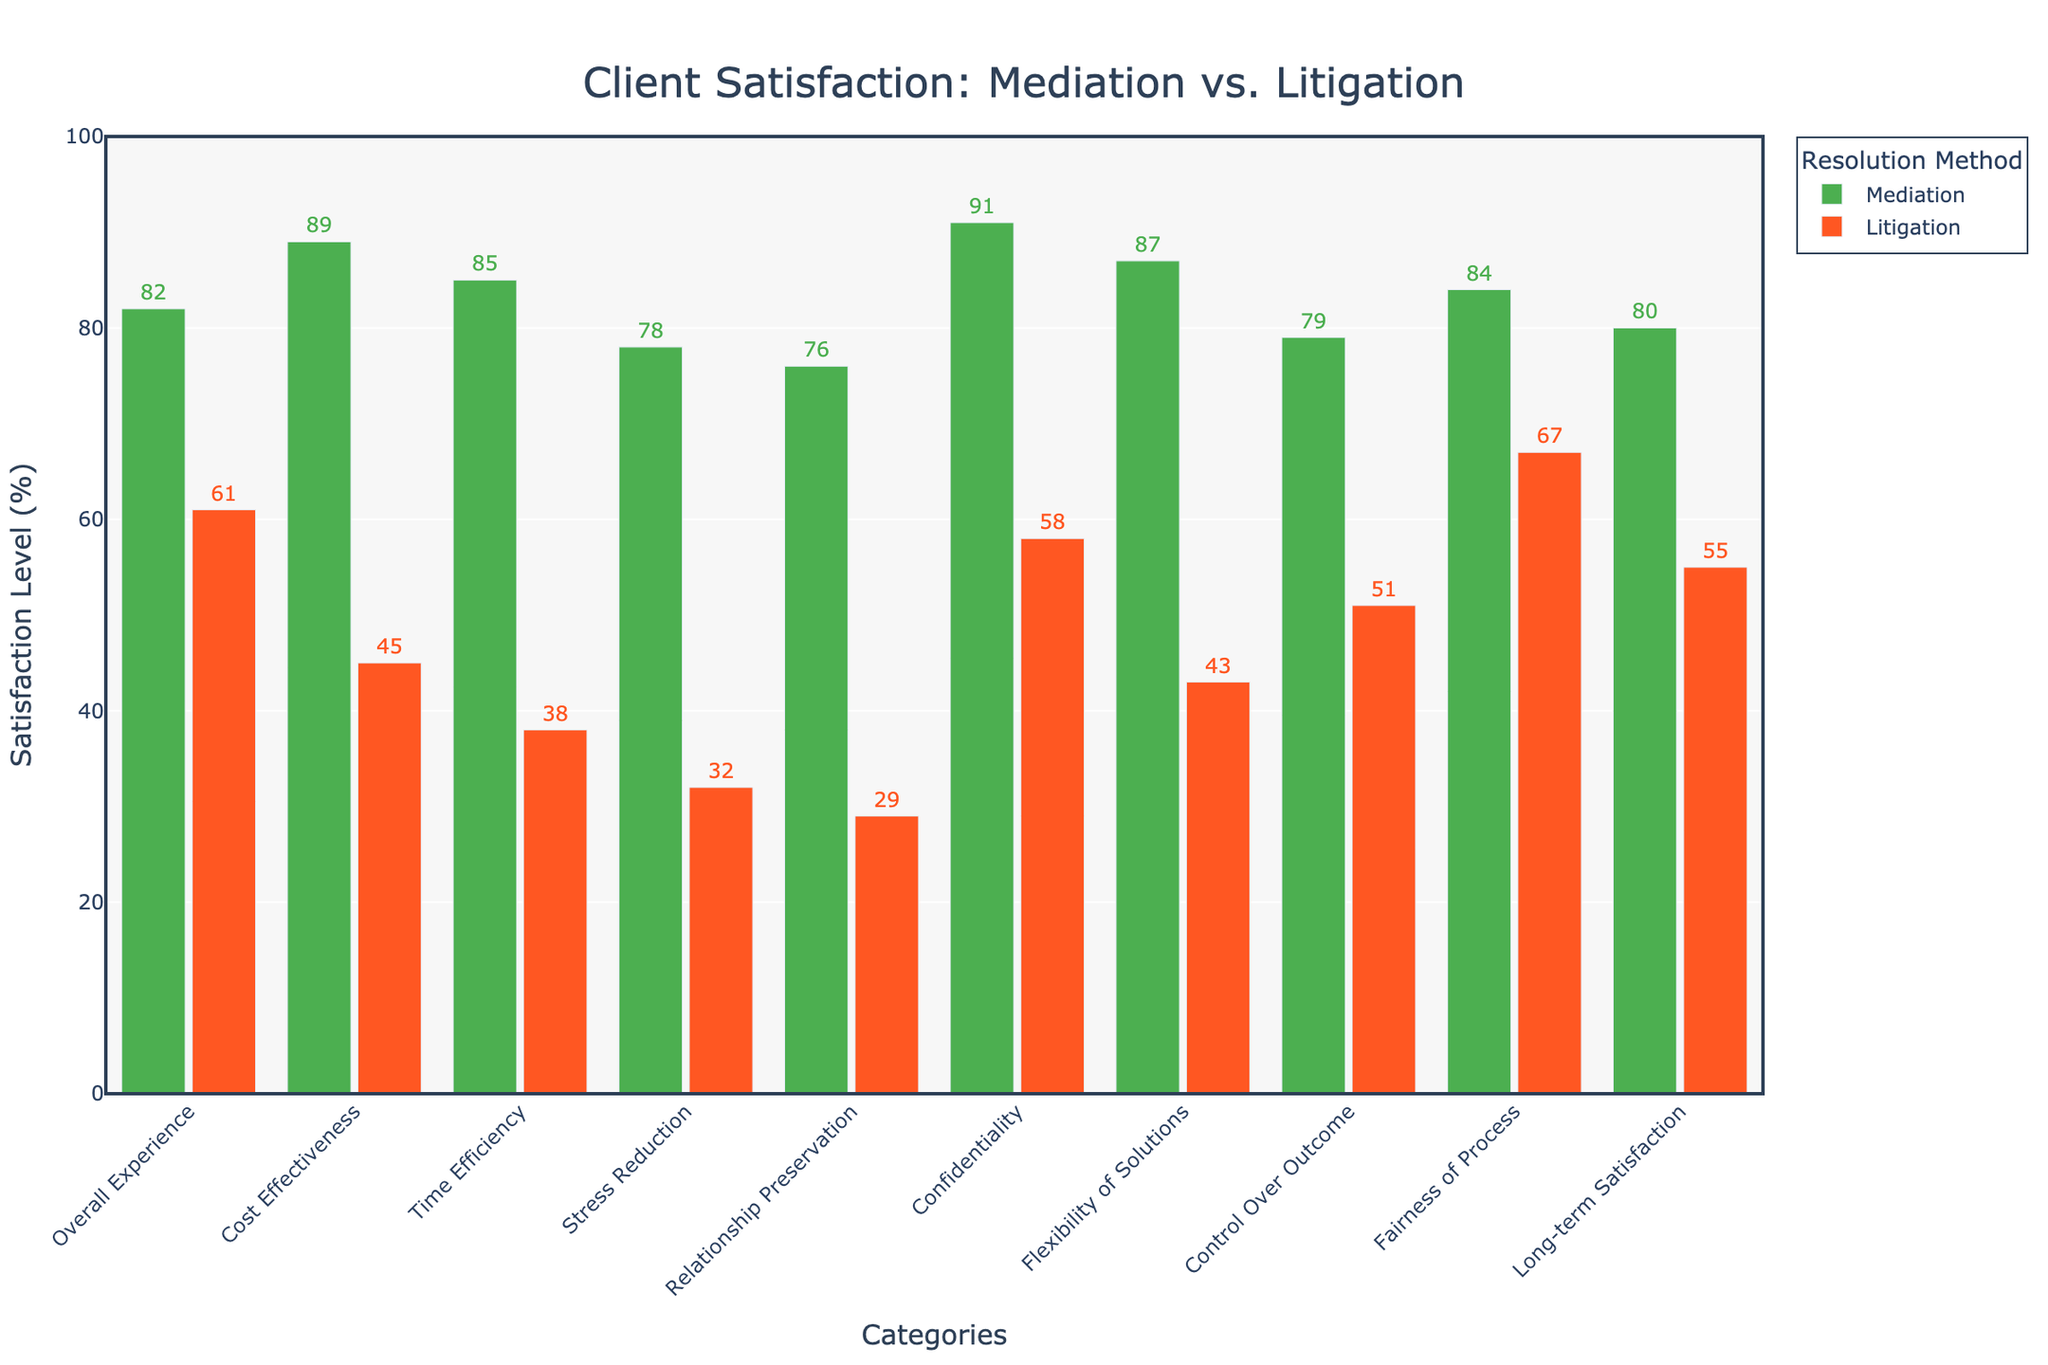Does Mediation or Litigation have a higher overall satisfaction level? To find which method has a higher overall satisfaction level, compare the heights of the bars for "Overall Experience" in the two methods. The bar for Mediation is taller, indicating a higher satisfaction level.
Answer: Mediation Which category shows the largest difference in satisfaction between Mediation and Litigation? To determine the category with the largest difference, calculate the differences for each category: Overall Experience (21%), Cost Effectiveness (44%), Time Efficiency (47%), Stress Reduction (46%), Relationship Preservation (47%), Confidentiality (33%), Flexibility of Solutions (44%), Control Over Outcome (28%), Fairness of Process (17%), Long-term Satisfaction (25%). Time Efficiency and Relationship Preservation both have a difference of 47%.
Answer: Time Efficiency and Relationship Preservation How much higher is the satisfaction level for Mediation compared to Litigation in the Cost Effectiveness category? Find the satisfaction levels for Mediation and Litigation in the Cost Effectiveness category, then subtract the Litigation level from the Mediation level: 89% - 45% = 44%.
Answer: 44% What is the average satisfaction level for Mediation across all categories? Add the satisfaction levels for all categories under Mediation and divide by the number of categories: (82 + 89 + 85 + 78 + 76 + 91 + 87 + 79 + 84 + 80) / 10 = 84.1%.
Answer: 84.1% In which category does Litigation have the smallest satisfaction percentage? Look for the shortest bar in the Litigation group. The category "Stress Reduction" shows the smallest satisfaction with 32%.
Answer: Stress Reduction Between Mediation and Litigation, which method shows a higher level of satisfaction in the category of Confidentiality? Compare the heights of the bars for "Confidentiality" in Mediation and Litigation. The Mediation bar is higher at 91%, compared to Litigation at 58%.
Answer: Mediation By how much does the satisfaction in Relationship Preservation differ between Mediation and Litigation? Compare the satisfaction levels in Relationship Preservation for both methods: Mediation is at 76% and Litigation at 29%. The difference is 76% - 29% = 47%.
Answer: 47% What is the total satisfaction percentage for Litigation across all categories? Add up the satisfaction percentages for each category under Litigation: 61 + 45 + 38 + 32 + 29 + 58 + 43 + 51 + 67 + 55 = 479%.
Answer: 479% Which method offers greater satisfaction in terms of Stress Reduction, and by how much? Compare the satisfaction percentages in Stress Reduction for both methods: Mediation is 78% and Litigation is 32%. Mediation offers greater satisfaction by 78% - 32% = 46%.
Answer: Mediation by 46% Is the satisfaction for Control Over Outcome in Mediation greater or lesser than that for Fairness of Process in Litigation? Compare Mediation's Control Over Outcome (79%) to Litigation's Fairness of Process (67%). Mediation's Control Over Outcome is greater.
Answer: Greater 